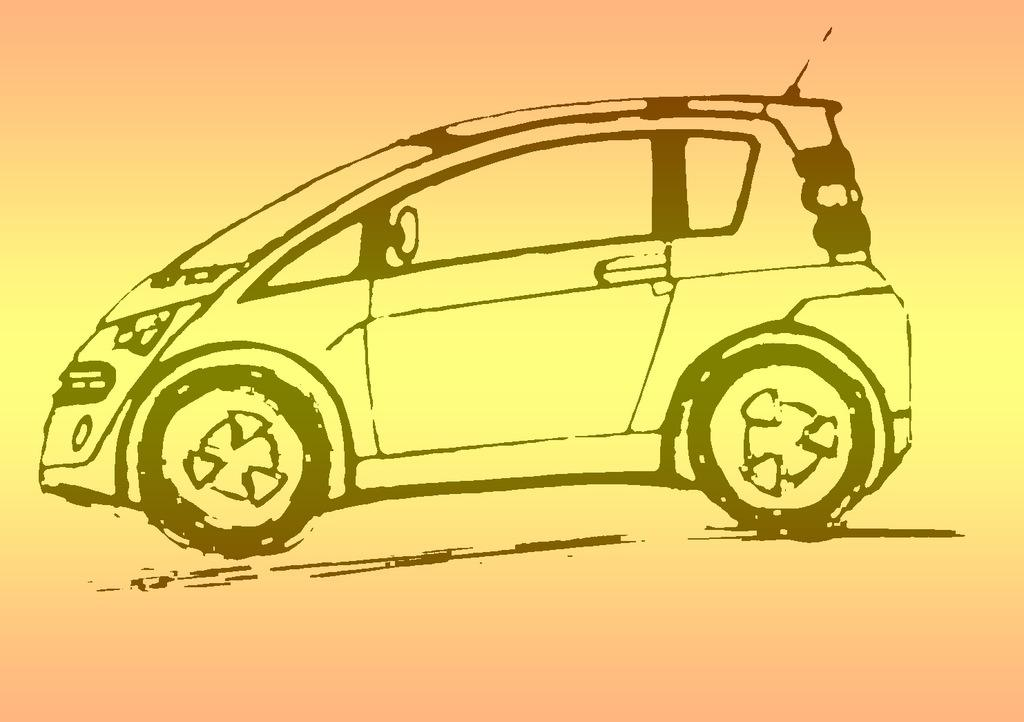What is depicted in the drawing in the image? There is a drawing of a car in the image. What colors are used in the drawing? The colors of the image are pale orange and pale yellow. What is the tendency of the bike in the image? There is no bike present in the image, so it is not possible to determine any tendency related to a bike. 